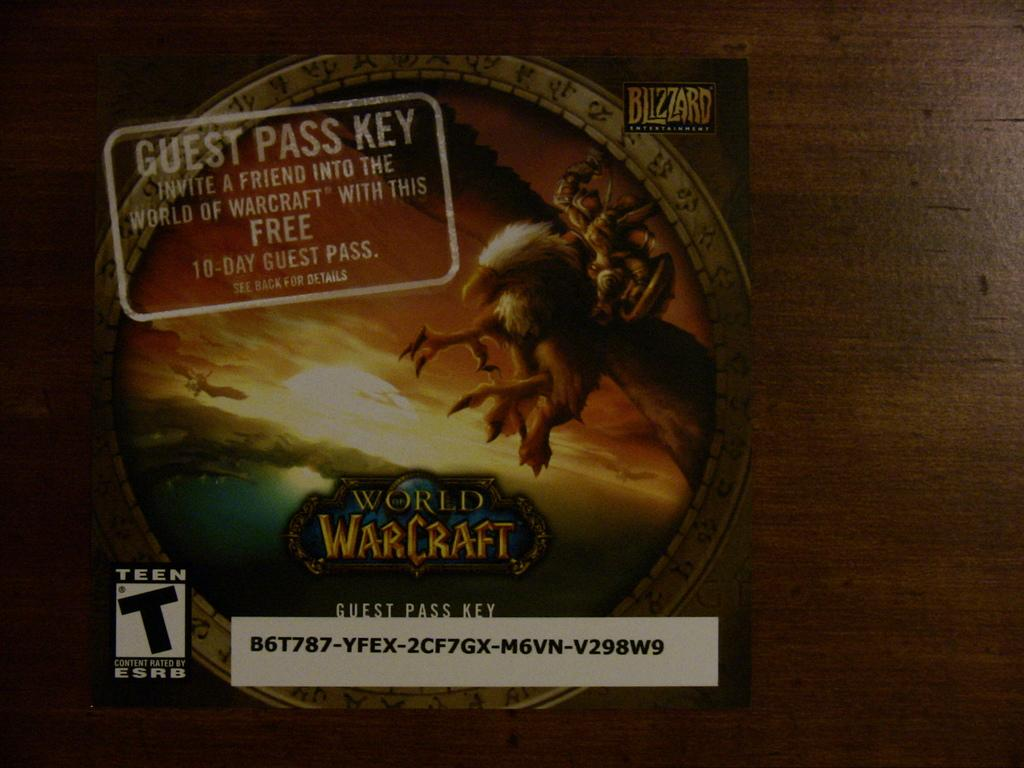<image>
Give a short and clear explanation of the subsequent image. card that is a guess pass for world of warcraft 